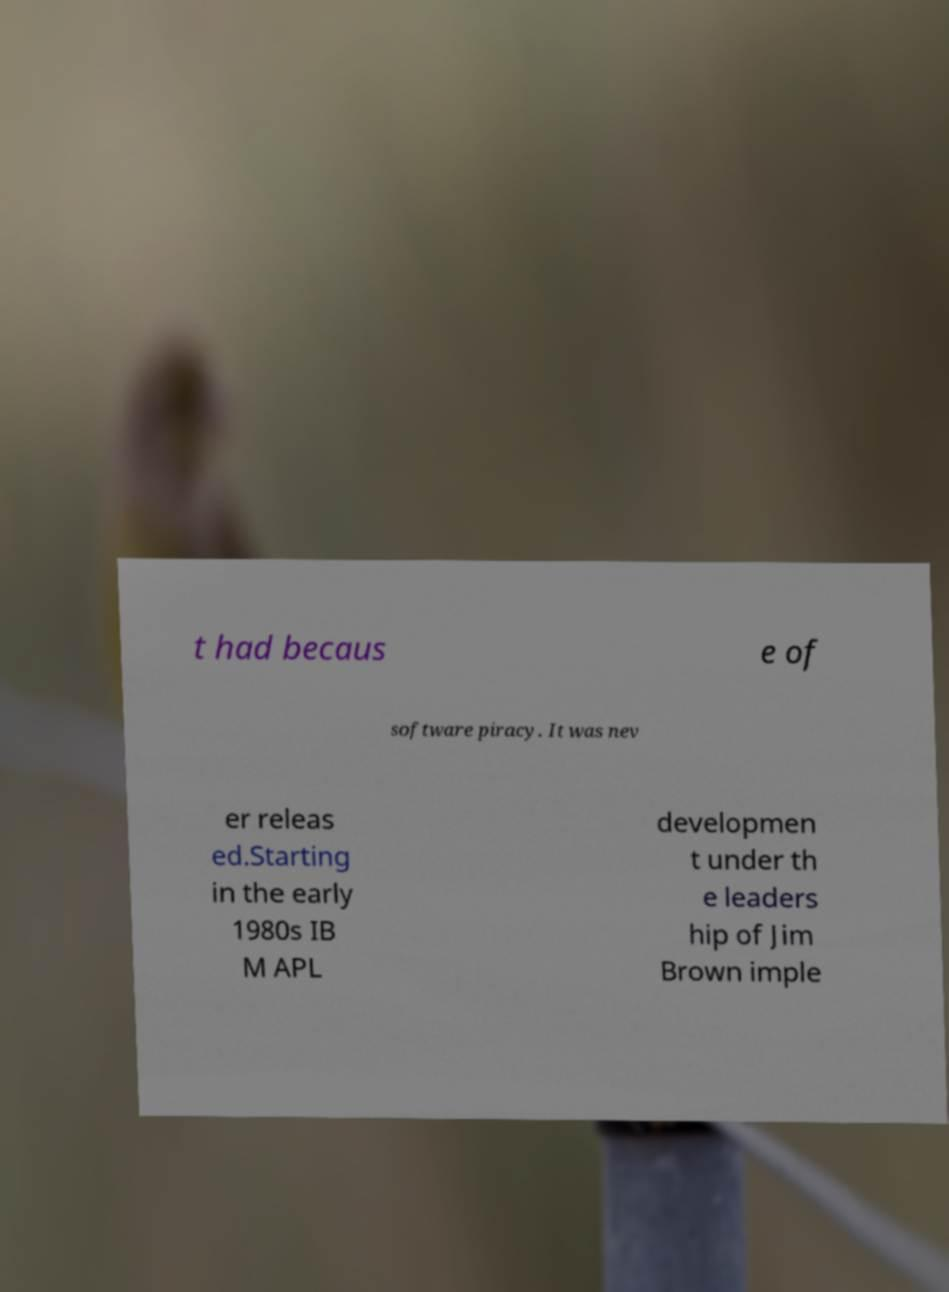Can you accurately transcribe the text from the provided image for me? t had becaus e of software piracy. It was nev er releas ed.Starting in the early 1980s IB M APL developmen t under th e leaders hip of Jim Brown imple 